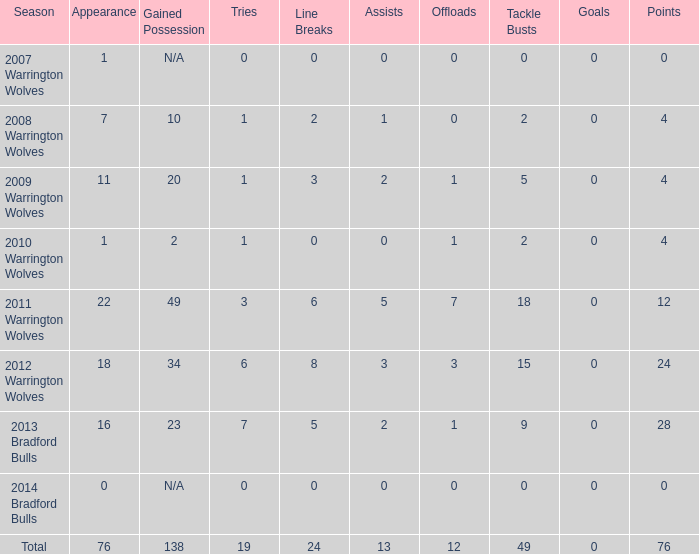What is the sum of appearance when goals is more than 0? None. 